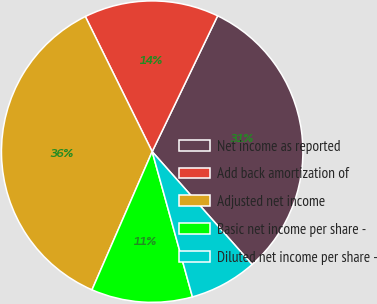Convert chart. <chart><loc_0><loc_0><loc_500><loc_500><pie_chart><fcel>Net income as reported<fcel>Add back amortization of<fcel>Adjusted net income<fcel>Basic net income per share -<fcel>Diluted net income per share -<nl><fcel>31.32%<fcel>14.46%<fcel>36.15%<fcel>10.84%<fcel>7.23%<nl></chart> 